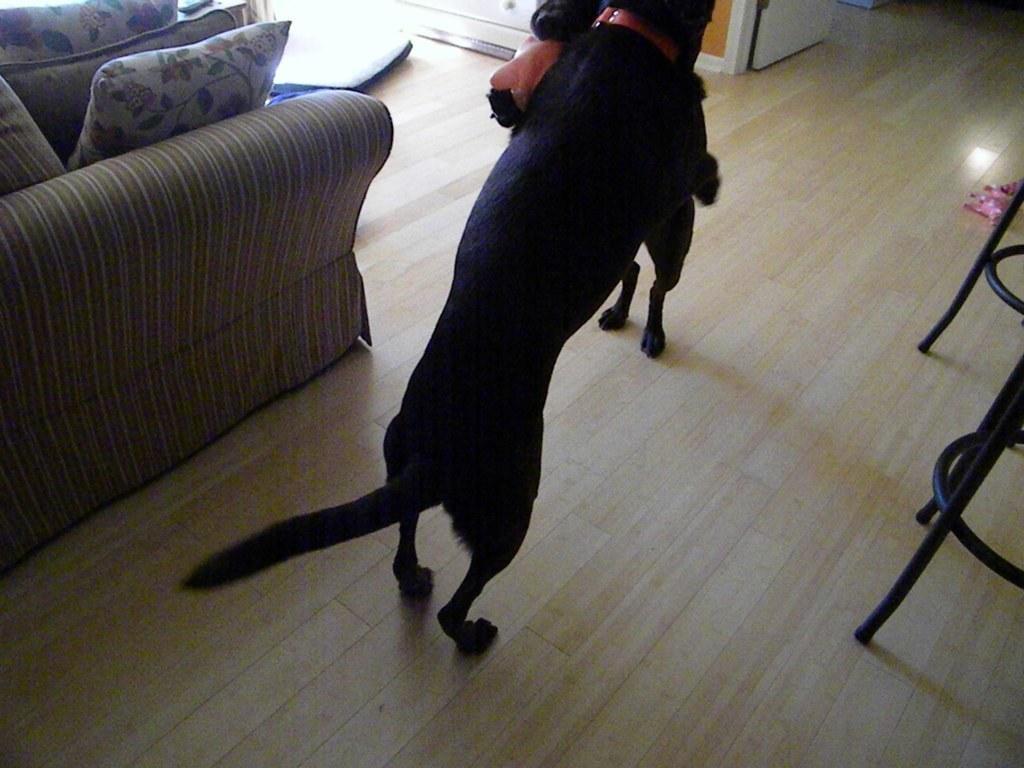How would you summarize this image in a sentence or two? In this image I can see two black colour dogs. I can also see a sofa and few cushions on it. 